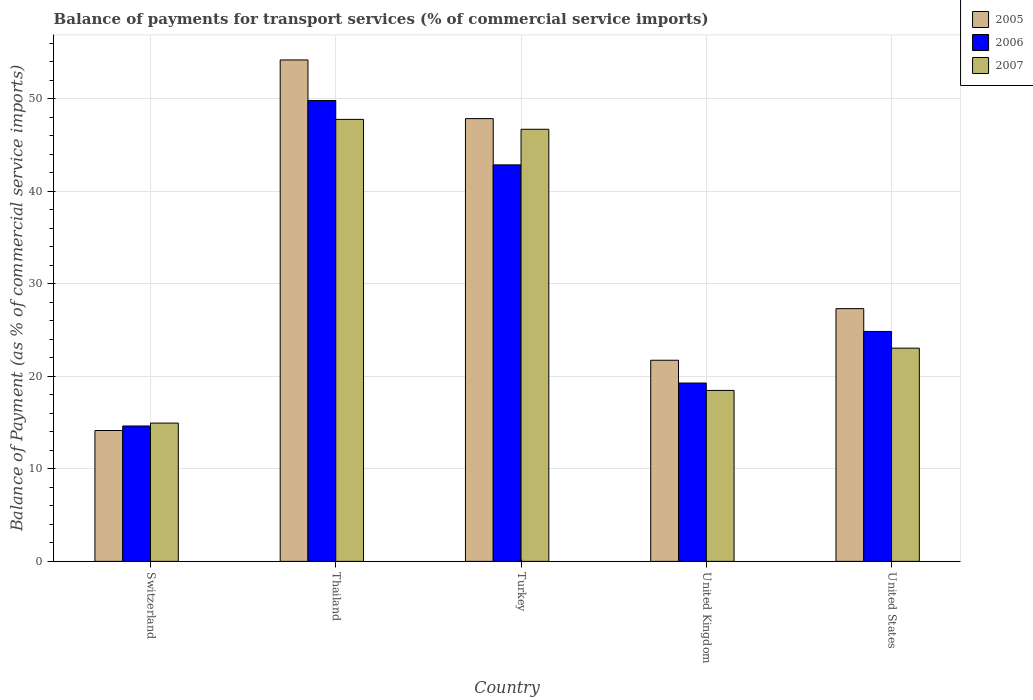How many different coloured bars are there?
Offer a very short reply. 3. Are the number of bars per tick equal to the number of legend labels?
Offer a very short reply. Yes. How many bars are there on the 5th tick from the left?
Your response must be concise. 3. How many bars are there on the 2nd tick from the right?
Keep it short and to the point. 3. What is the label of the 2nd group of bars from the left?
Ensure brevity in your answer.  Thailand. In how many cases, is the number of bars for a given country not equal to the number of legend labels?
Ensure brevity in your answer.  0. What is the balance of payments for transport services in 2006 in Switzerland?
Your response must be concise. 14.63. Across all countries, what is the maximum balance of payments for transport services in 2006?
Provide a short and direct response. 49.79. Across all countries, what is the minimum balance of payments for transport services in 2007?
Offer a terse response. 14.94. In which country was the balance of payments for transport services in 2006 maximum?
Give a very brief answer. Thailand. In which country was the balance of payments for transport services in 2007 minimum?
Make the answer very short. Switzerland. What is the total balance of payments for transport services in 2007 in the graph?
Make the answer very short. 150.9. What is the difference between the balance of payments for transport services in 2006 in Switzerland and that in Turkey?
Make the answer very short. -28.21. What is the difference between the balance of payments for transport services in 2005 in Switzerland and the balance of payments for transport services in 2007 in United Kingdom?
Offer a very short reply. -4.33. What is the average balance of payments for transport services in 2006 per country?
Keep it short and to the point. 30.28. What is the difference between the balance of payments for transport services of/in 2005 and balance of payments for transport services of/in 2006 in United Kingdom?
Keep it short and to the point. 2.46. What is the ratio of the balance of payments for transport services in 2007 in Thailand to that in Turkey?
Provide a short and direct response. 1.02. Is the balance of payments for transport services in 2006 in United Kingdom less than that in United States?
Your response must be concise. Yes. What is the difference between the highest and the second highest balance of payments for transport services in 2005?
Your response must be concise. -26.87. What is the difference between the highest and the lowest balance of payments for transport services in 2005?
Offer a very short reply. 40.04. Is the sum of the balance of payments for transport services in 2005 in United Kingdom and United States greater than the maximum balance of payments for transport services in 2006 across all countries?
Ensure brevity in your answer.  No. How many bars are there?
Your answer should be very brief. 15. How many countries are there in the graph?
Keep it short and to the point. 5. Does the graph contain grids?
Provide a short and direct response. Yes. Where does the legend appear in the graph?
Provide a short and direct response. Top right. How many legend labels are there?
Your answer should be compact. 3. How are the legend labels stacked?
Make the answer very short. Vertical. What is the title of the graph?
Provide a short and direct response. Balance of payments for transport services (% of commercial service imports). Does "2013" appear as one of the legend labels in the graph?
Provide a succinct answer. No. What is the label or title of the X-axis?
Offer a terse response. Country. What is the label or title of the Y-axis?
Ensure brevity in your answer.  Balance of Payment (as % of commercial service imports). What is the Balance of Payment (as % of commercial service imports) in 2005 in Switzerland?
Offer a very short reply. 14.14. What is the Balance of Payment (as % of commercial service imports) of 2006 in Switzerland?
Offer a terse response. 14.63. What is the Balance of Payment (as % of commercial service imports) of 2007 in Switzerland?
Provide a short and direct response. 14.94. What is the Balance of Payment (as % of commercial service imports) in 2005 in Thailand?
Ensure brevity in your answer.  54.18. What is the Balance of Payment (as % of commercial service imports) of 2006 in Thailand?
Your answer should be very brief. 49.79. What is the Balance of Payment (as % of commercial service imports) in 2007 in Thailand?
Provide a succinct answer. 47.76. What is the Balance of Payment (as % of commercial service imports) of 2005 in Turkey?
Offer a very short reply. 47.84. What is the Balance of Payment (as % of commercial service imports) in 2006 in Turkey?
Provide a succinct answer. 42.84. What is the Balance of Payment (as % of commercial service imports) in 2007 in Turkey?
Your answer should be very brief. 46.69. What is the Balance of Payment (as % of commercial service imports) of 2005 in United Kingdom?
Give a very brief answer. 21.73. What is the Balance of Payment (as % of commercial service imports) in 2006 in United Kingdom?
Ensure brevity in your answer.  19.27. What is the Balance of Payment (as % of commercial service imports) in 2007 in United Kingdom?
Offer a very short reply. 18.47. What is the Balance of Payment (as % of commercial service imports) in 2005 in United States?
Your answer should be compact. 27.31. What is the Balance of Payment (as % of commercial service imports) of 2006 in United States?
Give a very brief answer. 24.84. What is the Balance of Payment (as % of commercial service imports) in 2007 in United States?
Provide a succinct answer. 23.04. Across all countries, what is the maximum Balance of Payment (as % of commercial service imports) in 2005?
Ensure brevity in your answer.  54.18. Across all countries, what is the maximum Balance of Payment (as % of commercial service imports) in 2006?
Offer a terse response. 49.79. Across all countries, what is the maximum Balance of Payment (as % of commercial service imports) in 2007?
Offer a very short reply. 47.76. Across all countries, what is the minimum Balance of Payment (as % of commercial service imports) of 2005?
Provide a short and direct response. 14.14. Across all countries, what is the minimum Balance of Payment (as % of commercial service imports) in 2006?
Offer a terse response. 14.63. Across all countries, what is the minimum Balance of Payment (as % of commercial service imports) in 2007?
Ensure brevity in your answer.  14.94. What is the total Balance of Payment (as % of commercial service imports) of 2005 in the graph?
Offer a very short reply. 165.2. What is the total Balance of Payment (as % of commercial service imports) of 2006 in the graph?
Your response must be concise. 151.38. What is the total Balance of Payment (as % of commercial service imports) of 2007 in the graph?
Provide a succinct answer. 150.9. What is the difference between the Balance of Payment (as % of commercial service imports) in 2005 in Switzerland and that in Thailand?
Keep it short and to the point. -40.04. What is the difference between the Balance of Payment (as % of commercial service imports) of 2006 in Switzerland and that in Thailand?
Provide a succinct answer. -35.17. What is the difference between the Balance of Payment (as % of commercial service imports) of 2007 in Switzerland and that in Thailand?
Make the answer very short. -32.82. What is the difference between the Balance of Payment (as % of commercial service imports) in 2005 in Switzerland and that in Turkey?
Provide a short and direct response. -33.7. What is the difference between the Balance of Payment (as % of commercial service imports) of 2006 in Switzerland and that in Turkey?
Provide a short and direct response. -28.21. What is the difference between the Balance of Payment (as % of commercial service imports) of 2007 in Switzerland and that in Turkey?
Your answer should be very brief. -31.75. What is the difference between the Balance of Payment (as % of commercial service imports) in 2005 in Switzerland and that in United Kingdom?
Offer a very short reply. -7.59. What is the difference between the Balance of Payment (as % of commercial service imports) of 2006 in Switzerland and that in United Kingdom?
Make the answer very short. -4.64. What is the difference between the Balance of Payment (as % of commercial service imports) of 2007 in Switzerland and that in United Kingdom?
Offer a very short reply. -3.53. What is the difference between the Balance of Payment (as % of commercial service imports) in 2005 in Switzerland and that in United States?
Offer a very short reply. -13.17. What is the difference between the Balance of Payment (as % of commercial service imports) in 2006 in Switzerland and that in United States?
Give a very brief answer. -10.21. What is the difference between the Balance of Payment (as % of commercial service imports) of 2007 in Switzerland and that in United States?
Ensure brevity in your answer.  -8.1. What is the difference between the Balance of Payment (as % of commercial service imports) of 2005 in Thailand and that in Turkey?
Your answer should be very brief. 6.34. What is the difference between the Balance of Payment (as % of commercial service imports) of 2006 in Thailand and that in Turkey?
Make the answer very short. 6.95. What is the difference between the Balance of Payment (as % of commercial service imports) in 2007 in Thailand and that in Turkey?
Your response must be concise. 1.07. What is the difference between the Balance of Payment (as % of commercial service imports) in 2005 in Thailand and that in United Kingdom?
Provide a succinct answer. 32.45. What is the difference between the Balance of Payment (as % of commercial service imports) of 2006 in Thailand and that in United Kingdom?
Offer a terse response. 30.52. What is the difference between the Balance of Payment (as % of commercial service imports) of 2007 in Thailand and that in United Kingdom?
Give a very brief answer. 29.29. What is the difference between the Balance of Payment (as % of commercial service imports) of 2005 in Thailand and that in United States?
Offer a terse response. 26.87. What is the difference between the Balance of Payment (as % of commercial service imports) of 2006 in Thailand and that in United States?
Provide a succinct answer. 24.95. What is the difference between the Balance of Payment (as % of commercial service imports) of 2007 in Thailand and that in United States?
Offer a very short reply. 24.72. What is the difference between the Balance of Payment (as % of commercial service imports) of 2005 in Turkey and that in United Kingdom?
Keep it short and to the point. 26.11. What is the difference between the Balance of Payment (as % of commercial service imports) in 2006 in Turkey and that in United Kingdom?
Ensure brevity in your answer.  23.57. What is the difference between the Balance of Payment (as % of commercial service imports) of 2007 in Turkey and that in United Kingdom?
Ensure brevity in your answer.  28.22. What is the difference between the Balance of Payment (as % of commercial service imports) of 2005 in Turkey and that in United States?
Ensure brevity in your answer.  20.53. What is the difference between the Balance of Payment (as % of commercial service imports) in 2006 in Turkey and that in United States?
Your answer should be very brief. 18. What is the difference between the Balance of Payment (as % of commercial service imports) of 2007 in Turkey and that in United States?
Ensure brevity in your answer.  23.65. What is the difference between the Balance of Payment (as % of commercial service imports) in 2005 in United Kingdom and that in United States?
Give a very brief answer. -5.58. What is the difference between the Balance of Payment (as % of commercial service imports) of 2006 in United Kingdom and that in United States?
Offer a very short reply. -5.57. What is the difference between the Balance of Payment (as % of commercial service imports) in 2007 in United Kingdom and that in United States?
Keep it short and to the point. -4.57. What is the difference between the Balance of Payment (as % of commercial service imports) of 2005 in Switzerland and the Balance of Payment (as % of commercial service imports) of 2006 in Thailand?
Your answer should be compact. -35.66. What is the difference between the Balance of Payment (as % of commercial service imports) of 2005 in Switzerland and the Balance of Payment (as % of commercial service imports) of 2007 in Thailand?
Offer a very short reply. -33.62. What is the difference between the Balance of Payment (as % of commercial service imports) of 2006 in Switzerland and the Balance of Payment (as % of commercial service imports) of 2007 in Thailand?
Your answer should be compact. -33.13. What is the difference between the Balance of Payment (as % of commercial service imports) in 2005 in Switzerland and the Balance of Payment (as % of commercial service imports) in 2006 in Turkey?
Give a very brief answer. -28.7. What is the difference between the Balance of Payment (as % of commercial service imports) of 2005 in Switzerland and the Balance of Payment (as % of commercial service imports) of 2007 in Turkey?
Provide a short and direct response. -32.55. What is the difference between the Balance of Payment (as % of commercial service imports) in 2006 in Switzerland and the Balance of Payment (as % of commercial service imports) in 2007 in Turkey?
Offer a very short reply. -32.06. What is the difference between the Balance of Payment (as % of commercial service imports) of 2005 in Switzerland and the Balance of Payment (as % of commercial service imports) of 2006 in United Kingdom?
Provide a short and direct response. -5.13. What is the difference between the Balance of Payment (as % of commercial service imports) in 2005 in Switzerland and the Balance of Payment (as % of commercial service imports) in 2007 in United Kingdom?
Give a very brief answer. -4.33. What is the difference between the Balance of Payment (as % of commercial service imports) of 2006 in Switzerland and the Balance of Payment (as % of commercial service imports) of 2007 in United Kingdom?
Offer a very short reply. -3.84. What is the difference between the Balance of Payment (as % of commercial service imports) of 2005 in Switzerland and the Balance of Payment (as % of commercial service imports) of 2006 in United States?
Keep it short and to the point. -10.7. What is the difference between the Balance of Payment (as % of commercial service imports) of 2005 in Switzerland and the Balance of Payment (as % of commercial service imports) of 2007 in United States?
Keep it short and to the point. -8.9. What is the difference between the Balance of Payment (as % of commercial service imports) of 2006 in Switzerland and the Balance of Payment (as % of commercial service imports) of 2007 in United States?
Ensure brevity in your answer.  -8.41. What is the difference between the Balance of Payment (as % of commercial service imports) of 2005 in Thailand and the Balance of Payment (as % of commercial service imports) of 2006 in Turkey?
Offer a very short reply. 11.34. What is the difference between the Balance of Payment (as % of commercial service imports) in 2005 in Thailand and the Balance of Payment (as % of commercial service imports) in 2007 in Turkey?
Keep it short and to the point. 7.49. What is the difference between the Balance of Payment (as % of commercial service imports) in 2006 in Thailand and the Balance of Payment (as % of commercial service imports) in 2007 in Turkey?
Offer a terse response. 3.11. What is the difference between the Balance of Payment (as % of commercial service imports) in 2005 in Thailand and the Balance of Payment (as % of commercial service imports) in 2006 in United Kingdom?
Keep it short and to the point. 34.91. What is the difference between the Balance of Payment (as % of commercial service imports) in 2005 in Thailand and the Balance of Payment (as % of commercial service imports) in 2007 in United Kingdom?
Keep it short and to the point. 35.71. What is the difference between the Balance of Payment (as % of commercial service imports) in 2006 in Thailand and the Balance of Payment (as % of commercial service imports) in 2007 in United Kingdom?
Offer a terse response. 31.32. What is the difference between the Balance of Payment (as % of commercial service imports) in 2005 in Thailand and the Balance of Payment (as % of commercial service imports) in 2006 in United States?
Make the answer very short. 29.34. What is the difference between the Balance of Payment (as % of commercial service imports) in 2005 in Thailand and the Balance of Payment (as % of commercial service imports) in 2007 in United States?
Give a very brief answer. 31.14. What is the difference between the Balance of Payment (as % of commercial service imports) in 2006 in Thailand and the Balance of Payment (as % of commercial service imports) in 2007 in United States?
Ensure brevity in your answer.  26.76. What is the difference between the Balance of Payment (as % of commercial service imports) in 2005 in Turkey and the Balance of Payment (as % of commercial service imports) in 2006 in United Kingdom?
Ensure brevity in your answer.  28.57. What is the difference between the Balance of Payment (as % of commercial service imports) of 2005 in Turkey and the Balance of Payment (as % of commercial service imports) of 2007 in United Kingdom?
Your response must be concise. 29.37. What is the difference between the Balance of Payment (as % of commercial service imports) of 2006 in Turkey and the Balance of Payment (as % of commercial service imports) of 2007 in United Kingdom?
Ensure brevity in your answer.  24.37. What is the difference between the Balance of Payment (as % of commercial service imports) in 2005 in Turkey and the Balance of Payment (as % of commercial service imports) in 2006 in United States?
Offer a terse response. 23. What is the difference between the Balance of Payment (as % of commercial service imports) in 2005 in Turkey and the Balance of Payment (as % of commercial service imports) in 2007 in United States?
Keep it short and to the point. 24.8. What is the difference between the Balance of Payment (as % of commercial service imports) in 2006 in Turkey and the Balance of Payment (as % of commercial service imports) in 2007 in United States?
Provide a succinct answer. 19.8. What is the difference between the Balance of Payment (as % of commercial service imports) in 2005 in United Kingdom and the Balance of Payment (as % of commercial service imports) in 2006 in United States?
Make the answer very short. -3.11. What is the difference between the Balance of Payment (as % of commercial service imports) of 2005 in United Kingdom and the Balance of Payment (as % of commercial service imports) of 2007 in United States?
Your answer should be compact. -1.31. What is the difference between the Balance of Payment (as % of commercial service imports) of 2006 in United Kingdom and the Balance of Payment (as % of commercial service imports) of 2007 in United States?
Keep it short and to the point. -3.77. What is the average Balance of Payment (as % of commercial service imports) in 2005 per country?
Offer a terse response. 33.04. What is the average Balance of Payment (as % of commercial service imports) in 2006 per country?
Your response must be concise. 30.28. What is the average Balance of Payment (as % of commercial service imports) of 2007 per country?
Provide a succinct answer. 30.18. What is the difference between the Balance of Payment (as % of commercial service imports) of 2005 and Balance of Payment (as % of commercial service imports) of 2006 in Switzerland?
Your answer should be compact. -0.49. What is the difference between the Balance of Payment (as % of commercial service imports) of 2005 and Balance of Payment (as % of commercial service imports) of 2007 in Switzerland?
Your response must be concise. -0.8. What is the difference between the Balance of Payment (as % of commercial service imports) in 2006 and Balance of Payment (as % of commercial service imports) in 2007 in Switzerland?
Make the answer very short. -0.31. What is the difference between the Balance of Payment (as % of commercial service imports) of 2005 and Balance of Payment (as % of commercial service imports) of 2006 in Thailand?
Offer a very short reply. 4.39. What is the difference between the Balance of Payment (as % of commercial service imports) in 2005 and Balance of Payment (as % of commercial service imports) in 2007 in Thailand?
Offer a terse response. 6.42. What is the difference between the Balance of Payment (as % of commercial service imports) of 2006 and Balance of Payment (as % of commercial service imports) of 2007 in Thailand?
Keep it short and to the point. 2.04. What is the difference between the Balance of Payment (as % of commercial service imports) in 2005 and Balance of Payment (as % of commercial service imports) in 2006 in Turkey?
Provide a short and direct response. 5. What is the difference between the Balance of Payment (as % of commercial service imports) of 2005 and Balance of Payment (as % of commercial service imports) of 2007 in Turkey?
Offer a terse response. 1.15. What is the difference between the Balance of Payment (as % of commercial service imports) in 2006 and Balance of Payment (as % of commercial service imports) in 2007 in Turkey?
Provide a short and direct response. -3.85. What is the difference between the Balance of Payment (as % of commercial service imports) of 2005 and Balance of Payment (as % of commercial service imports) of 2006 in United Kingdom?
Provide a short and direct response. 2.46. What is the difference between the Balance of Payment (as % of commercial service imports) in 2005 and Balance of Payment (as % of commercial service imports) in 2007 in United Kingdom?
Your answer should be compact. 3.26. What is the difference between the Balance of Payment (as % of commercial service imports) in 2006 and Balance of Payment (as % of commercial service imports) in 2007 in United Kingdom?
Ensure brevity in your answer.  0.8. What is the difference between the Balance of Payment (as % of commercial service imports) of 2005 and Balance of Payment (as % of commercial service imports) of 2006 in United States?
Provide a succinct answer. 2.47. What is the difference between the Balance of Payment (as % of commercial service imports) in 2005 and Balance of Payment (as % of commercial service imports) in 2007 in United States?
Keep it short and to the point. 4.27. What is the difference between the Balance of Payment (as % of commercial service imports) in 2006 and Balance of Payment (as % of commercial service imports) in 2007 in United States?
Make the answer very short. 1.8. What is the ratio of the Balance of Payment (as % of commercial service imports) of 2005 in Switzerland to that in Thailand?
Your response must be concise. 0.26. What is the ratio of the Balance of Payment (as % of commercial service imports) of 2006 in Switzerland to that in Thailand?
Offer a terse response. 0.29. What is the ratio of the Balance of Payment (as % of commercial service imports) in 2007 in Switzerland to that in Thailand?
Provide a succinct answer. 0.31. What is the ratio of the Balance of Payment (as % of commercial service imports) of 2005 in Switzerland to that in Turkey?
Your response must be concise. 0.3. What is the ratio of the Balance of Payment (as % of commercial service imports) in 2006 in Switzerland to that in Turkey?
Keep it short and to the point. 0.34. What is the ratio of the Balance of Payment (as % of commercial service imports) in 2007 in Switzerland to that in Turkey?
Ensure brevity in your answer.  0.32. What is the ratio of the Balance of Payment (as % of commercial service imports) in 2005 in Switzerland to that in United Kingdom?
Ensure brevity in your answer.  0.65. What is the ratio of the Balance of Payment (as % of commercial service imports) of 2006 in Switzerland to that in United Kingdom?
Provide a succinct answer. 0.76. What is the ratio of the Balance of Payment (as % of commercial service imports) in 2007 in Switzerland to that in United Kingdom?
Offer a terse response. 0.81. What is the ratio of the Balance of Payment (as % of commercial service imports) in 2005 in Switzerland to that in United States?
Your answer should be compact. 0.52. What is the ratio of the Balance of Payment (as % of commercial service imports) in 2006 in Switzerland to that in United States?
Your answer should be very brief. 0.59. What is the ratio of the Balance of Payment (as % of commercial service imports) of 2007 in Switzerland to that in United States?
Offer a terse response. 0.65. What is the ratio of the Balance of Payment (as % of commercial service imports) in 2005 in Thailand to that in Turkey?
Offer a terse response. 1.13. What is the ratio of the Balance of Payment (as % of commercial service imports) of 2006 in Thailand to that in Turkey?
Provide a succinct answer. 1.16. What is the ratio of the Balance of Payment (as % of commercial service imports) of 2007 in Thailand to that in Turkey?
Your answer should be compact. 1.02. What is the ratio of the Balance of Payment (as % of commercial service imports) in 2005 in Thailand to that in United Kingdom?
Your answer should be compact. 2.49. What is the ratio of the Balance of Payment (as % of commercial service imports) of 2006 in Thailand to that in United Kingdom?
Keep it short and to the point. 2.58. What is the ratio of the Balance of Payment (as % of commercial service imports) in 2007 in Thailand to that in United Kingdom?
Your answer should be compact. 2.59. What is the ratio of the Balance of Payment (as % of commercial service imports) in 2005 in Thailand to that in United States?
Your answer should be very brief. 1.98. What is the ratio of the Balance of Payment (as % of commercial service imports) in 2006 in Thailand to that in United States?
Keep it short and to the point. 2. What is the ratio of the Balance of Payment (as % of commercial service imports) in 2007 in Thailand to that in United States?
Your answer should be compact. 2.07. What is the ratio of the Balance of Payment (as % of commercial service imports) in 2005 in Turkey to that in United Kingdom?
Provide a short and direct response. 2.2. What is the ratio of the Balance of Payment (as % of commercial service imports) in 2006 in Turkey to that in United Kingdom?
Your answer should be compact. 2.22. What is the ratio of the Balance of Payment (as % of commercial service imports) in 2007 in Turkey to that in United Kingdom?
Offer a terse response. 2.53. What is the ratio of the Balance of Payment (as % of commercial service imports) of 2005 in Turkey to that in United States?
Offer a terse response. 1.75. What is the ratio of the Balance of Payment (as % of commercial service imports) in 2006 in Turkey to that in United States?
Offer a very short reply. 1.72. What is the ratio of the Balance of Payment (as % of commercial service imports) of 2007 in Turkey to that in United States?
Your answer should be compact. 2.03. What is the ratio of the Balance of Payment (as % of commercial service imports) of 2005 in United Kingdom to that in United States?
Make the answer very short. 0.8. What is the ratio of the Balance of Payment (as % of commercial service imports) in 2006 in United Kingdom to that in United States?
Keep it short and to the point. 0.78. What is the ratio of the Balance of Payment (as % of commercial service imports) of 2007 in United Kingdom to that in United States?
Your response must be concise. 0.8. What is the difference between the highest and the second highest Balance of Payment (as % of commercial service imports) of 2005?
Make the answer very short. 6.34. What is the difference between the highest and the second highest Balance of Payment (as % of commercial service imports) in 2006?
Make the answer very short. 6.95. What is the difference between the highest and the second highest Balance of Payment (as % of commercial service imports) of 2007?
Ensure brevity in your answer.  1.07. What is the difference between the highest and the lowest Balance of Payment (as % of commercial service imports) of 2005?
Keep it short and to the point. 40.04. What is the difference between the highest and the lowest Balance of Payment (as % of commercial service imports) in 2006?
Make the answer very short. 35.17. What is the difference between the highest and the lowest Balance of Payment (as % of commercial service imports) of 2007?
Make the answer very short. 32.82. 